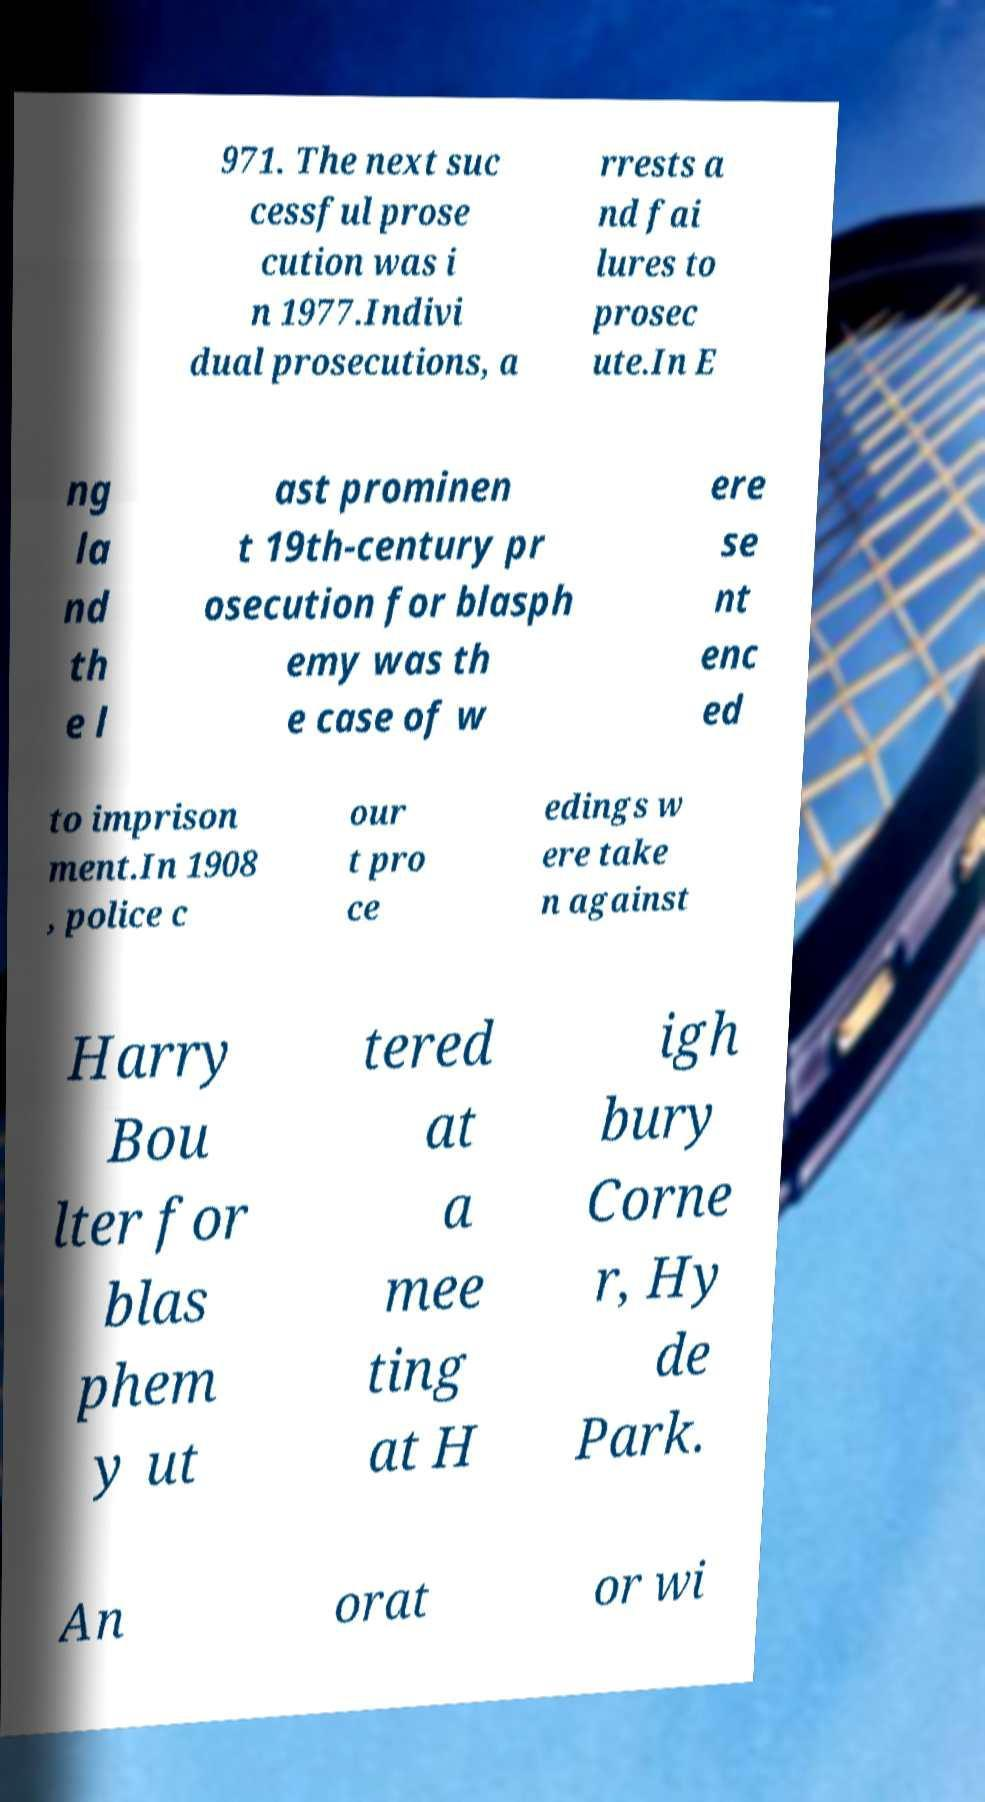There's text embedded in this image that I need extracted. Can you transcribe it verbatim? 971. The next suc cessful prose cution was i n 1977.Indivi dual prosecutions, a rrests a nd fai lures to prosec ute.In E ng la nd th e l ast prominen t 19th-century pr osecution for blasph emy was th e case of w ere se nt enc ed to imprison ment.In 1908 , police c our t pro ce edings w ere take n against Harry Bou lter for blas phem y ut tered at a mee ting at H igh bury Corne r, Hy de Park. An orat or wi 